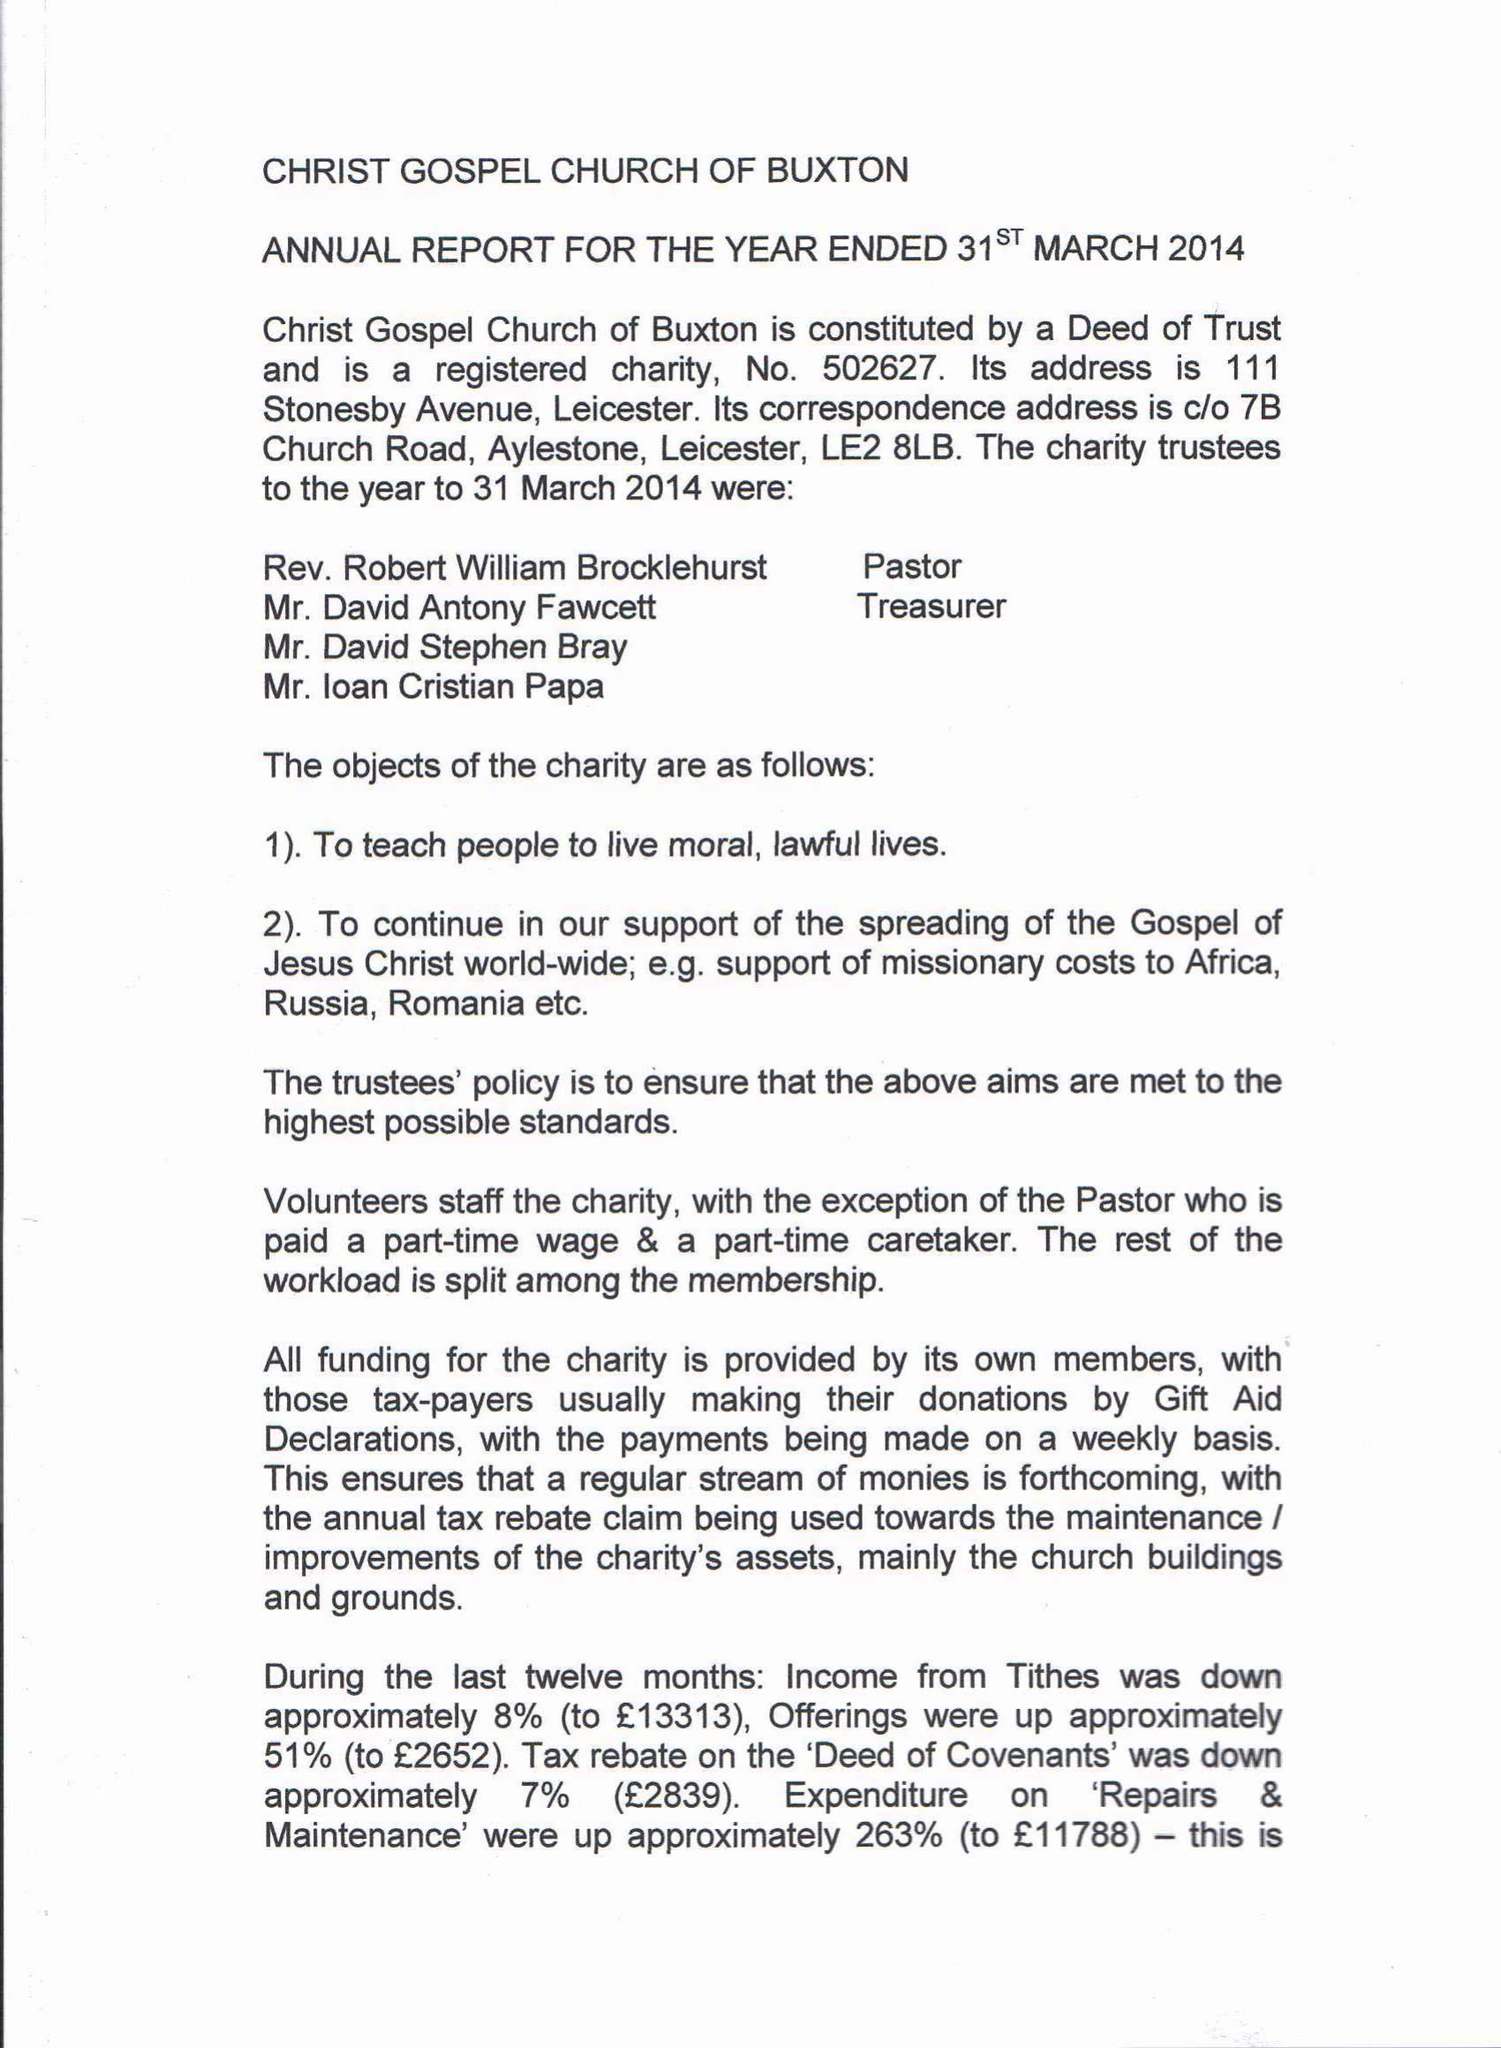What is the value for the charity_number?
Answer the question using a single word or phrase. 502627 